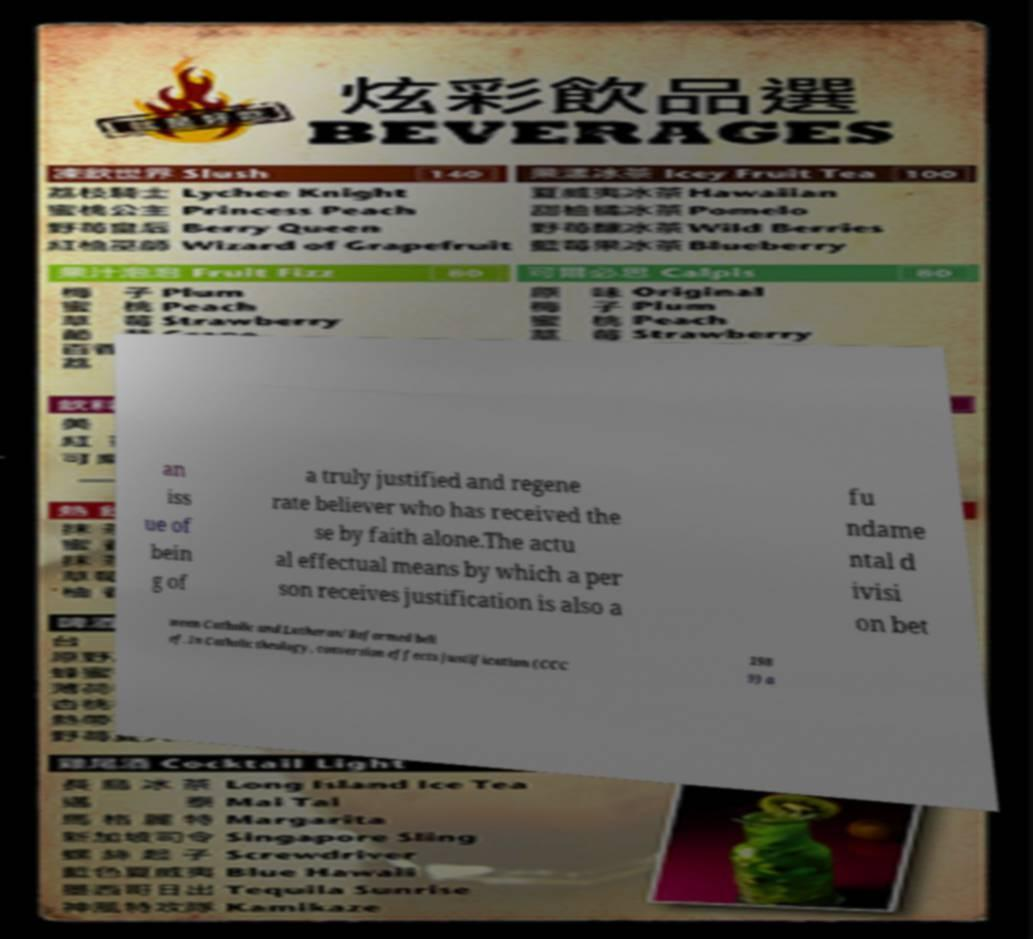Could you extract and type out the text from this image? an iss ue of bein g of a truly justified and regene rate believer who has received the se by faith alone.The actu al effectual means by which a per son receives justification is also a fu ndame ntal d ivisi on bet ween Catholic and Lutheran/Reformed beli ef. In Catholic theology, conversion effects justification (CCC 198 9) a 